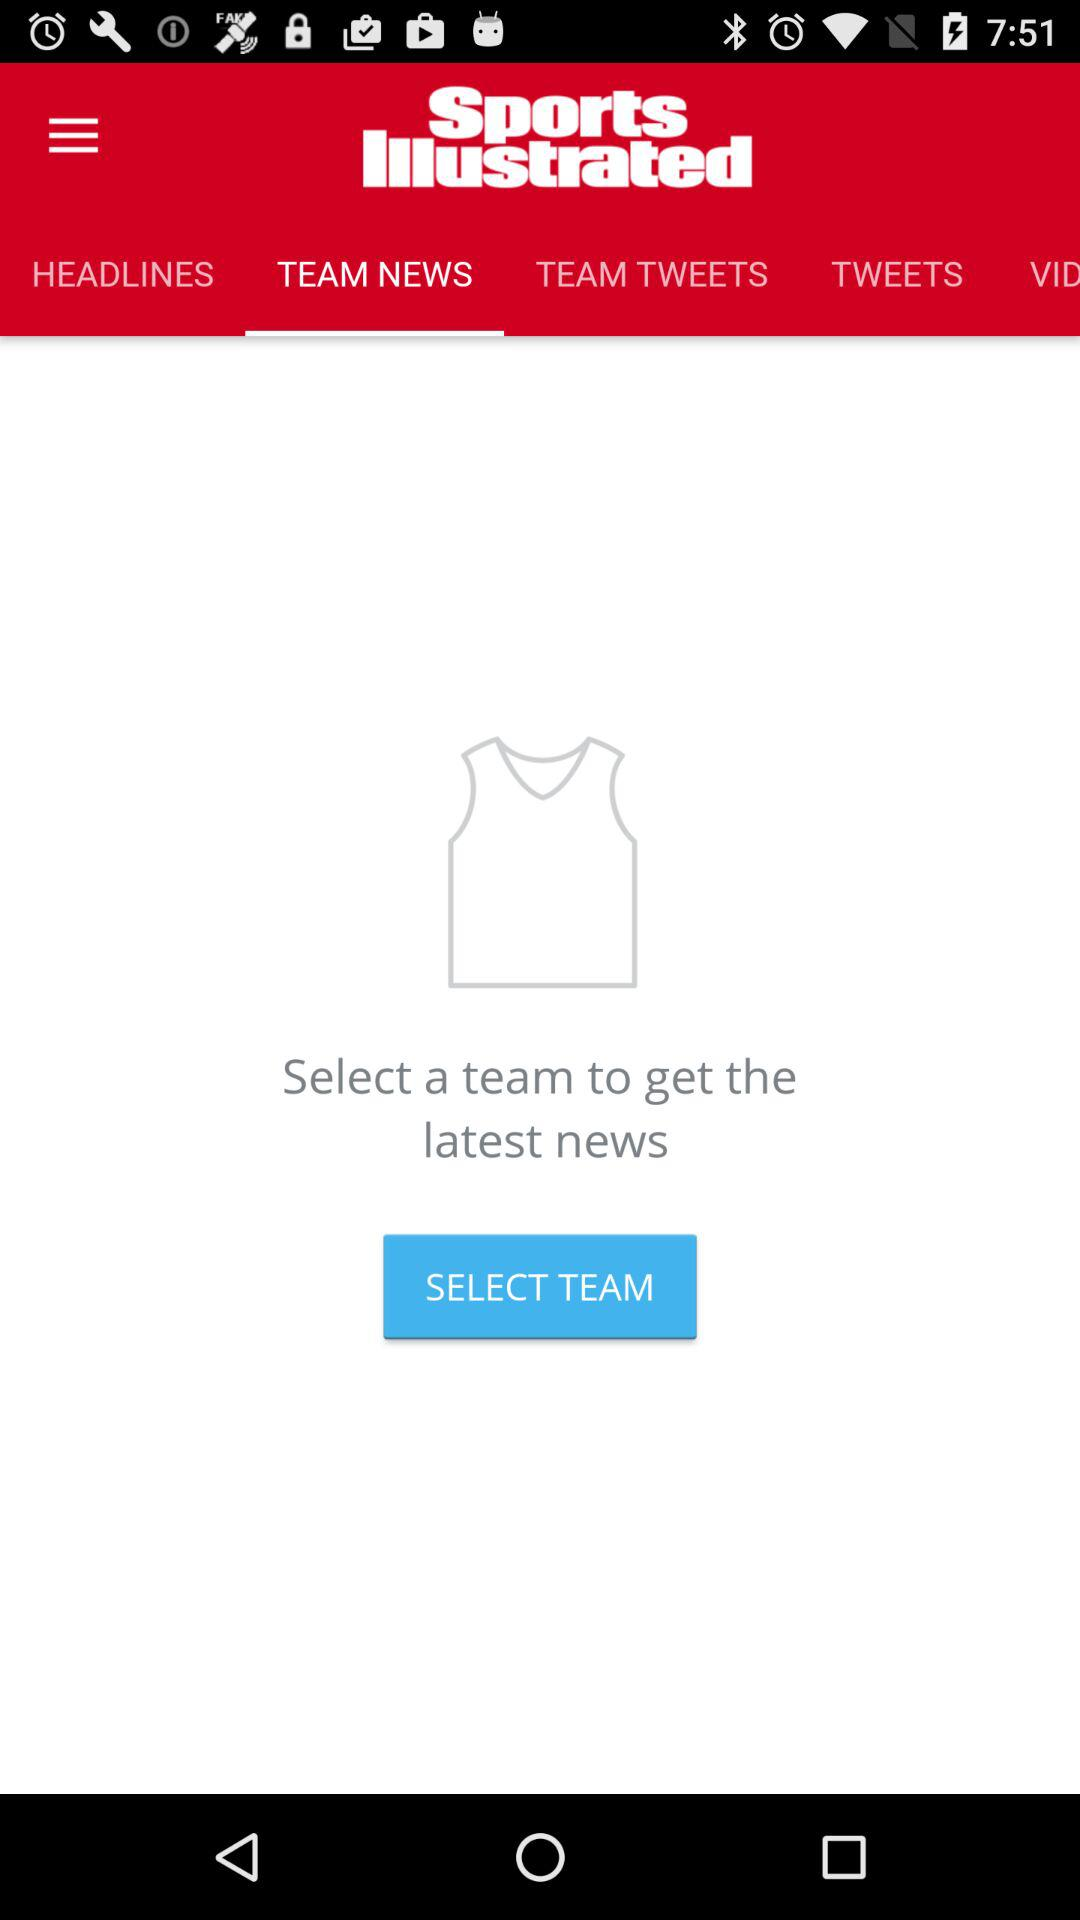Which tab of "Sports Illustrated" am I on? You are on the "TEAM NEWS" tab. 